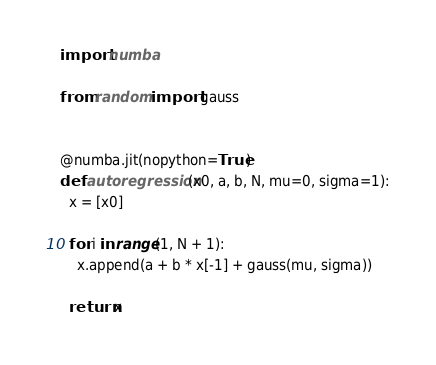<code> <loc_0><loc_0><loc_500><loc_500><_Python_>import numba

from random import gauss


@numba.jit(nopython=True)
def autoregression(x0, a, b, N, mu=0, sigma=1):
  x = [x0]

  for i in range(1, N + 1):
    x.append(a + b * x[-1] + gauss(mu, sigma))

  return x
</code> 